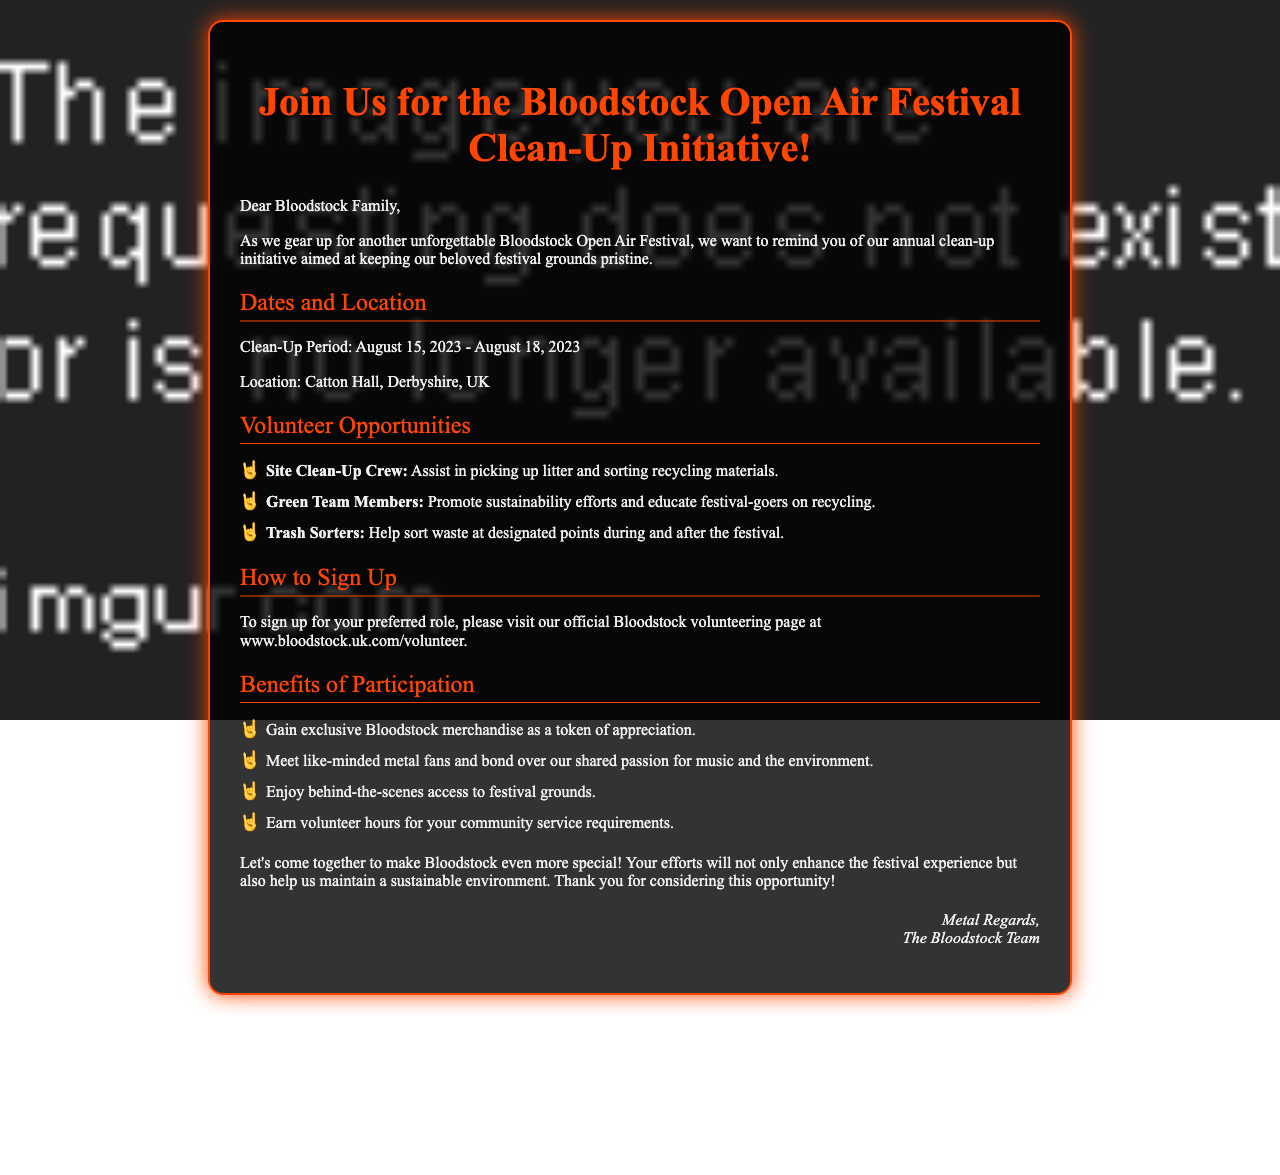What are the clean-up dates? The clean-up period is specified in the document, which is from August 15, 2023, to August 18, 2023.
Answer: August 15, 2023 - August 18, 2023 Where is the clean-up taking place? The location is mentioned in the document as Catton Hall, Derbyshire, UK.
Answer: Catton Hall, Derbyshire, UK What role involves promoting sustainability? One of the volunteer opportunities listed is for promoting sustainability efforts and educating festival-goers.
Answer: Green Team Members What benefit involves exclusivity? The document states one of the benefits of participation is exclusive Bloodstock merchandise.
Answer: Exclusive Bloodstock merchandise How can you sign up for volunteering? The document provides a specific website link for signing up for volunteering roles.
Answer: www.bloodstock.uk.com/volunteer What is the purpose of the letter? The letter's purpose is to remind readers about the annual clean-up initiative and encourage participation.
Answer: To remind about the clean-up initiative Which team helps sort waste? The document describes a volunteer role specifically focused on waste sorting.
Answer: Trash Sorters What is a benefit of meeting fellow volunteers? The document highlights bonding over shared passion as a benefit of participation.
Answer: Bond over shared passion for music and the environment 